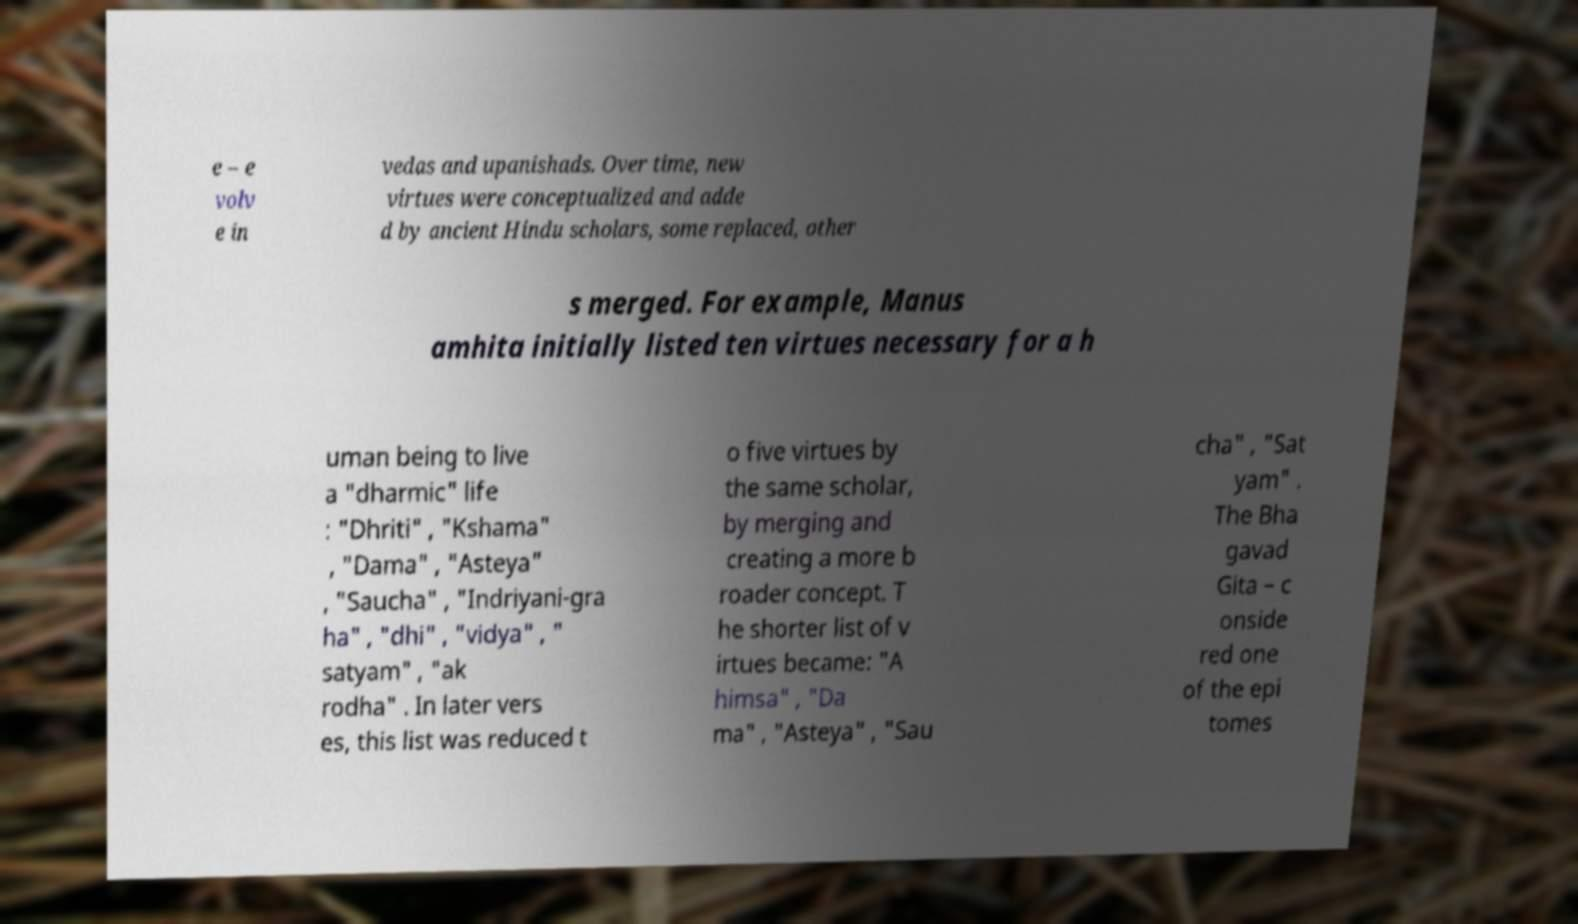Could you assist in decoding the text presented in this image and type it out clearly? e – e volv e in vedas and upanishads. Over time, new virtues were conceptualized and adde d by ancient Hindu scholars, some replaced, other s merged. For example, Manus amhita initially listed ten virtues necessary for a h uman being to live a "dharmic" life : "Dhriti" , "Kshama" , "Dama" , "Asteya" , "Saucha" , "Indriyani-gra ha" , "dhi" , "vidya" , " satyam" , "ak rodha" . In later vers es, this list was reduced t o five virtues by the same scholar, by merging and creating a more b roader concept. T he shorter list of v irtues became: "A himsa" , "Da ma" , "Asteya" , "Sau cha" , "Sat yam" . The Bha gavad Gita – c onside red one of the epi tomes 